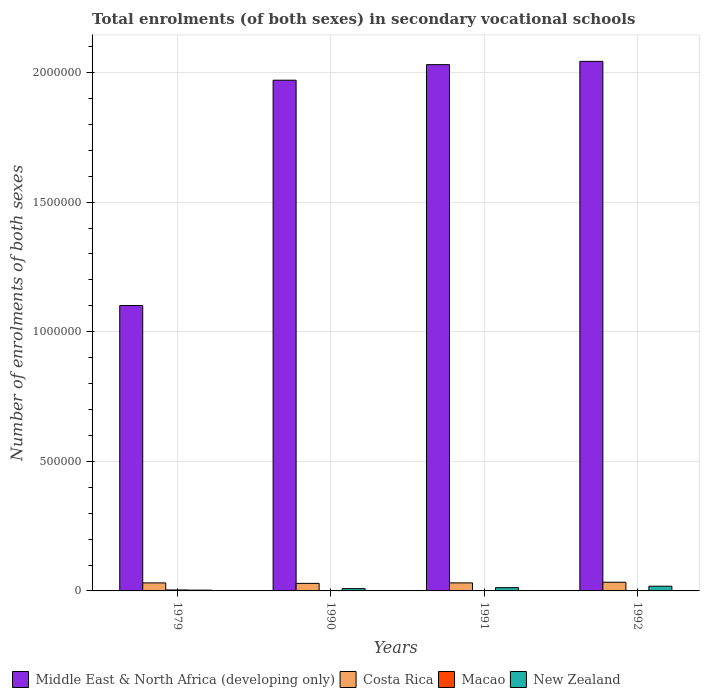How many groups of bars are there?
Ensure brevity in your answer.  4. Are the number of bars per tick equal to the number of legend labels?
Provide a short and direct response. Yes. How many bars are there on the 3rd tick from the left?
Provide a short and direct response. 4. What is the label of the 1st group of bars from the left?
Keep it short and to the point. 1979. What is the number of enrolments in secondary schools in Costa Rica in 1992?
Make the answer very short. 3.35e+04. Across all years, what is the maximum number of enrolments in secondary schools in Costa Rica?
Your answer should be compact. 3.35e+04. Across all years, what is the minimum number of enrolments in secondary schools in Middle East & North Africa (developing only)?
Offer a very short reply. 1.10e+06. In which year was the number of enrolments in secondary schools in New Zealand minimum?
Keep it short and to the point. 1979. What is the total number of enrolments in secondary schools in Middle East & North Africa (developing only) in the graph?
Offer a very short reply. 7.14e+06. What is the difference between the number of enrolments in secondary schools in Middle East & North Africa (developing only) in 1979 and that in 1991?
Your answer should be compact. -9.29e+05. What is the difference between the number of enrolments in secondary schools in Middle East & North Africa (developing only) in 1991 and the number of enrolments in secondary schools in Macao in 1990?
Your answer should be compact. 2.03e+06. What is the average number of enrolments in secondary schools in Middle East & North Africa (developing only) per year?
Provide a short and direct response. 1.79e+06. In the year 1990, what is the difference between the number of enrolments in secondary schools in New Zealand and number of enrolments in secondary schools in Middle East & North Africa (developing only)?
Your response must be concise. -1.96e+06. What is the ratio of the number of enrolments in secondary schools in Macao in 1990 to that in 1991?
Keep it short and to the point. 0.96. What is the difference between the highest and the second highest number of enrolments in secondary schools in Costa Rica?
Provide a succinct answer. 2579. What is the difference between the highest and the lowest number of enrolments in secondary schools in New Zealand?
Your answer should be very brief. 1.52e+04. Is the sum of the number of enrolments in secondary schools in New Zealand in 1991 and 1992 greater than the maximum number of enrolments in secondary schools in Middle East & North Africa (developing only) across all years?
Offer a very short reply. No. Is it the case that in every year, the sum of the number of enrolments in secondary schools in New Zealand and number of enrolments in secondary schools in Middle East & North Africa (developing only) is greater than the sum of number of enrolments in secondary schools in Macao and number of enrolments in secondary schools in Costa Rica?
Provide a succinct answer. No. What does the 4th bar from the left in 1991 represents?
Make the answer very short. New Zealand. What does the 4th bar from the right in 1992 represents?
Your response must be concise. Middle East & North Africa (developing only). Is it the case that in every year, the sum of the number of enrolments in secondary schools in New Zealand and number of enrolments in secondary schools in Macao is greater than the number of enrolments in secondary schools in Costa Rica?
Provide a succinct answer. No. How many years are there in the graph?
Give a very brief answer. 4. What is the difference between two consecutive major ticks on the Y-axis?
Provide a short and direct response. 5.00e+05. Where does the legend appear in the graph?
Your answer should be very brief. Bottom left. How many legend labels are there?
Your answer should be very brief. 4. What is the title of the graph?
Offer a terse response. Total enrolments (of both sexes) in secondary vocational schools. Does "Macao" appear as one of the legend labels in the graph?
Your response must be concise. Yes. What is the label or title of the X-axis?
Your answer should be compact. Years. What is the label or title of the Y-axis?
Keep it short and to the point. Number of enrolments of both sexes. What is the Number of enrolments of both sexes in Middle East & North Africa (developing only) in 1979?
Your answer should be very brief. 1.10e+06. What is the Number of enrolments of both sexes in Costa Rica in 1979?
Ensure brevity in your answer.  3.09e+04. What is the Number of enrolments of both sexes of Macao in 1979?
Offer a very short reply. 3703. What is the Number of enrolments of both sexes of New Zealand in 1979?
Make the answer very short. 2977. What is the Number of enrolments of both sexes in Middle East & North Africa (developing only) in 1990?
Keep it short and to the point. 1.97e+06. What is the Number of enrolments of both sexes in Costa Rica in 1990?
Your answer should be compact. 2.91e+04. What is the Number of enrolments of both sexes of Macao in 1990?
Your answer should be compact. 697. What is the Number of enrolments of both sexes in New Zealand in 1990?
Keep it short and to the point. 8901. What is the Number of enrolments of both sexes of Middle East & North Africa (developing only) in 1991?
Your response must be concise. 2.03e+06. What is the Number of enrolments of both sexes of Costa Rica in 1991?
Provide a succinct answer. 3.10e+04. What is the Number of enrolments of both sexes in Macao in 1991?
Ensure brevity in your answer.  725. What is the Number of enrolments of both sexes in New Zealand in 1991?
Give a very brief answer. 1.25e+04. What is the Number of enrolments of both sexes of Middle East & North Africa (developing only) in 1992?
Your answer should be very brief. 2.04e+06. What is the Number of enrolments of both sexes in Costa Rica in 1992?
Keep it short and to the point. 3.35e+04. What is the Number of enrolments of both sexes of Macao in 1992?
Offer a very short reply. 754. What is the Number of enrolments of both sexes in New Zealand in 1992?
Ensure brevity in your answer.  1.82e+04. Across all years, what is the maximum Number of enrolments of both sexes in Middle East & North Africa (developing only)?
Your response must be concise. 2.04e+06. Across all years, what is the maximum Number of enrolments of both sexes in Costa Rica?
Offer a very short reply. 3.35e+04. Across all years, what is the maximum Number of enrolments of both sexes of Macao?
Make the answer very short. 3703. Across all years, what is the maximum Number of enrolments of both sexes of New Zealand?
Offer a terse response. 1.82e+04. Across all years, what is the minimum Number of enrolments of both sexes in Middle East & North Africa (developing only)?
Keep it short and to the point. 1.10e+06. Across all years, what is the minimum Number of enrolments of both sexes in Costa Rica?
Give a very brief answer. 2.91e+04. Across all years, what is the minimum Number of enrolments of both sexes in Macao?
Keep it short and to the point. 697. Across all years, what is the minimum Number of enrolments of both sexes of New Zealand?
Your answer should be compact. 2977. What is the total Number of enrolments of both sexes in Middle East & North Africa (developing only) in the graph?
Provide a succinct answer. 7.14e+06. What is the total Number of enrolments of both sexes in Costa Rica in the graph?
Your response must be concise. 1.25e+05. What is the total Number of enrolments of both sexes in Macao in the graph?
Give a very brief answer. 5879. What is the total Number of enrolments of both sexes in New Zealand in the graph?
Keep it short and to the point. 4.26e+04. What is the difference between the Number of enrolments of both sexes of Middle East & North Africa (developing only) in 1979 and that in 1990?
Provide a succinct answer. -8.69e+05. What is the difference between the Number of enrolments of both sexes in Costa Rica in 1979 and that in 1990?
Offer a terse response. 1821. What is the difference between the Number of enrolments of both sexes of Macao in 1979 and that in 1990?
Ensure brevity in your answer.  3006. What is the difference between the Number of enrolments of both sexes in New Zealand in 1979 and that in 1990?
Your answer should be compact. -5924. What is the difference between the Number of enrolments of both sexes in Middle East & North Africa (developing only) in 1979 and that in 1991?
Keep it short and to the point. -9.29e+05. What is the difference between the Number of enrolments of both sexes of Costa Rica in 1979 and that in 1991?
Your response must be concise. -36. What is the difference between the Number of enrolments of both sexes of Macao in 1979 and that in 1991?
Offer a terse response. 2978. What is the difference between the Number of enrolments of both sexes of New Zealand in 1979 and that in 1991?
Make the answer very short. -9560. What is the difference between the Number of enrolments of both sexes in Middle East & North Africa (developing only) in 1979 and that in 1992?
Give a very brief answer. -9.42e+05. What is the difference between the Number of enrolments of both sexes of Costa Rica in 1979 and that in 1992?
Keep it short and to the point. -2615. What is the difference between the Number of enrolments of both sexes of Macao in 1979 and that in 1992?
Make the answer very short. 2949. What is the difference between the Number of enrolments of both sexes in New Zealand in 1979 and that in 1992?
Ensure brevity in your answer.  -1.52e+04. What is the difference between the Number of enrolments of both sexes of Middle East & North Africa (developing only) in 1990 and that in 1991?
Make the answer very short. -5.99e+04. What is the difference between the Number of enrolments of both sexes of Costa Rica in 1990 and that in 1991?
Ensure brevity in your answer.  -1857. What is the difference between the Number of enrolments of both sexes of New Zealand in 1990 and that in 1991?
Provide a succinct answer. -3636. What is the difference between the Number of enrolments of both sexes in Middle East & North Africa (developing only) in 1990 and that in 1992?
Your answer should be compact. -7.27e+04. What is the difference between the Number of enrolments of both sexes in Costa Rica in 1990 and that in 1992?
Make the answer very short. -4436. What is the difference between the Number of enrolments of both sexes in Macao in 1990 and that in 1992?
Offer a very short reply. -57. What is the difference between the Number of enrolments of both sexes in New Zealand in 1990 and that in 1992?
Your answer should be very brief. -9249. What is the difference between the Number of enrolments of both sexes of Middle East & North Africa (developing only) in 1991 and that in 1992?
Provide a succinct answer. -1.27e+04. What is the difference between the Number of enrolments of both sexes of Costa Rica in 1991 and that in 1992?
Your answer should be very brief. -2579. What is the difference between the Number of enrolments of both sexes of New Zealand in 1991 and that in 1992?
Your answer should be compact. -5613. What is the difference between the Number of enrolments of both sexes in Middle East & North Africa (developing only) in 1979 and the Number of enrolments of both sexes in Costa Rica in 1990?
Offer a terse response. 1.07e+06. What is the difference between the Number of enrolments of both sexes of Middle East & North Africa (developing only) in 1979 and the Number of enrolments of both sexes of Macao in 1990?
Ensure brevity in your answer.  1.10e+06. What is the difference between the Number of enrolments of both sexes in Middle East & North Africa (developing only) in 1979 and the Number of enrolments of both sexes in New Zealand in 1990?
Keep it short and to the point. 1.09e+06. What is the difference between the Number of enrolments of both sexes in Costa Rica in 1979 and the Number of enrolments of both sexes in Macao in 1990?
Ensure brevity in your answer.  3.02e+04. What is the difference between the Number of enrolments of both sexes in Costa Rica in 1979 and the Number of enrolments of both sexes in New Zealand in 1990?
Provide a succinct answer. 2.20e+04. What is the difference between the Number of enrolments of both sexes in Macao in 1979 and the Number of enrolments of both sexes in New Zealand in 1990?
Your answer should be very brief. -5198. What is the difference between the Number of enrolments of both sexes of Middle East & North Africa (developing only) in 1979 and the Number of enrolments of both sexes of Costa Rica in 1991?
Your answer should be compact. 1.07e+06. What is the difference between the Number of enrolments of both sexes in Middle East & North Africa (developing only) in 1979 and the Number of enrolments of both sexes in Macao in 1991?
Keep it short and to the point. 1.10e+06. What is the difference between the Number of enrolments of both sexes in Middle East & North Africa (developing only) in 1979 and the Number of enrolments of both sexes in New Zealand in 1991?
Make the answer very short. 1.09e+06. What is the difference between the Number of enrolments of both sexes of Costa Rica in 1979 and the Number of enrolments of both sexes of Macao in 1991?
Offer a terse response. 3.02e+04. What is the difference between the Number of enrolments of both sexes in Costa Rica in 1979 and the Number of enrolments of both sexes in New Zealand in 1991?
Ensure brevity in your answer.  1.84e+04. What is the difference between the Number of enrolments of both sexes of Macao in 1979 and the Number of enrolments of both sexes of New Zealand in 1991?
Offer a very short reply. -8834. What is the difference between the Number of enrolments of both sexes in Middle East & North Africa (developing only) in 1979 and the Number of enrolments of both sexes in Costa Rica in 1992?
Keep it short and to the point. 1.07e+06. What is the difference between the Number of enrolments of both sexes of Middle East & North Africa (developing only) in 1979 and the Number of enrolments of both sexes of Macao in 1992?
Offer a very short reply. 1.10e+06. What is the difference between the Number of enrolments of both sexes of Middle East & North Africa (developing only) in 1979 and the Number of enrolments of both sexes of New Zealand in 1992?
Your response must be concise. 1.08e+06. What is the difference between the Number of enrolments of both sexes of Costa Rica in 1979 and the Number of enrolments of both sexes of Macao in 1992?
Provide a succinct answer. 3.02e+04. What is the difference between the Number of enrolments of both sexes in Costa Rica in 1979 and the Number of enrolments of both sexes in New Zealand in 1992?
Your answer should be very brief. 1.28e+04. What is the difference between the Number of enrolments of both sexes in Macao in 1979 and the Number of enrolments of both sexes in New Zealand in 1992?
Your answer should be compact. -1.44e+04. What is the difference between the Number of enrolments of both sexes of Middle East & North Africa (developing only) in 1990 and the Number of enrolments of both sexes of Costa Rica in 1991?
Provide a succinct answer. 1.94e+06. What is the difference between the Number of enrolments of both sexes of Middle East & North Africa (developing only) in 1990 and the Number of enrolments of both sexes of Macao in 1991?
Ensure brevity in your answer.  1.97e+06. What is the difference between the Number of enrolments of both sexes in Middle East & North Africa (developing only) in 1990 and the Number of enrolments of both sexes in New Zealand in 1991?
Your answer should be compact. 1.96e+06. What is the difference between the Number of enrolments of both sexes of Costa Rica in 1990 and the Number of enrolments of both sexes of Macao in 1991?
Make the answer very short. 2.84e+04. What is the difference between the Number of enrolments of both sexes in Costa Rica in 1990 and the Number of enrolments of both sexes in New Zealand in 1991?
Provide a short and direct response. 1.66e+04. What is the difference between the Number of enrolments of both sexes of Macao in 1990 and the Number of enrolments of both sexes of New Zealand in 1991?
Provide a short and direct response. -1.18e+04. What is the difference between the Number of enrolments of both sexes in Middle East & North Africa (developing only) in 1990 and the Number of enrolments of both sexes in Costa Rica in 1992?
Make the answer very short. 1.94e+06. What is the difference between the Number of enrolments of both sexes of Middle East & North Africa (developing only) in 1990 and the Number of enrolments of both sexes of Macao in 1992?
Make the answer very short. 1.97e+06. What is the difference between the Number of enrolments of both sexes in Middle East & North Africa (developing only) in 1990 and the Number of enrolments of both sexes in New Zealand in 1992?
Offer a very short reply. 1.95e+06. What is the difference between the Number of enrolments of both sexes of Costa Rica in 1990 and the Number of enrolments of both sexes of Macao in 1992?
Your response must be concise. 2.83e+04. What is the difference between the Number of enrolments of both sexes of Costa Rica in 1990 and the Number of enrolments of both sexes of New Zealand in 1992?
Your answer should be very brief. 1.10e+04. What is the difference between the Number of enrolments of both sexes in Macao in 1990 and the Number of enrolments of both sexes in New Zealand in 1992?
Your response must be concise. -1.75e+04. What is the difference between the Number of enrolments of both sexes in Middle East & North Africa (developing only) in 1991 and the Number of enrolments of both sexes in Costa Rica in 1992?
Offer a terse response. 2.00e+06. What is the difference between the Number of enrolments of both sexes in Middle East & North Africa (developing only) in 1991 and the Number of enrolments of both sexes in Macao in 1992?
Provide a short and direct response. 2.03e+06. What is the difference between the Number of enrolments of both sexes of Middle East & North Africa (developing only) in 1991 and the Number of enrolments of both sexes of New Zealand in 1992?
Your answer should be compact. 2.01e+06. What is the difference between the Number of enrolments of both sexes in Costa Rica in 1991 and the Number of enrolments of both sexes in Macao in 1992?
Give a very brief answer. 3.02e+04. What is the difference between the Number of enrolments of both sexes of Costa Rica in 1991 and the Number of enrolments of both sexes of New Zealand in 1992?
Your answer should be very brief. 1.28e+04. What is the difference between the Number of enrolments of both sexes of Macao in 1991 and the Number of enrolments of both sexes of New Zealand in 1992?
Ensure brevity in your answer.  -1.74e+04. What is the average Number of enrolments of both sexes in Middle East & North Africa (developing only) per year?
Your answer should be very brief. 1.79e+06. What is the average Number of enrolments of both sexes in Costa Rica per year?
Your answer should be compact. 3.11e+04. What is the average Number of enrolments of both sexes in Macao per year?
Provide a short and direct response. 1469.75. What is the average Number of enrolments of both sexes of New Zealand per year?
Keep it short and to the point. 1.06e+04. In the year 1979, what is the difference between the Number of enrolments of both sexes in Middle East & North Africa (developing only) and Number of enrolments of both sexes in Costa Rica?
Ensure brevity in your answer.  1.07e+06. In the year 1979, what is the difference between the Number of enrolments of both sexes of Middle East & North Africa (developing only) and Number of enrolments of both sexes of Macao?
Your answer should be very brief. 1.10e+06. In the year 1979, what is the difference between the Number of enrolments of both sexes in Middle East & North Africa (developing only) and Number of enrolments of both sexes in New Zealand?
Your answer should be very brief. 1.10e+06. In the year 1979, what is the difference between the Number of enrolments of both sexes of Costa Rica and Number of enrolments of both sexes of Macao?
Your response must be concise. 2.72e+04. In the year 1979, what is the difference between the Number of enrolments of both sexes of Costa Rica and Number of enrolments of both sexes of New Zealand?
Your answer should be compact. 2.79e+04. In the year 1979, what is the difference between the Number of enrolments of both sexes in Macao and Number of enrolments of both sexes in New Zealand?
Your response must be concise. 726. In the year 1990, what is the difference between the Number of enrolments of both sexes in Middle East & North Africa (developing only) and Number of enrolments of both sexes in Costa Rica?
Make the answer very short. 1.94e+06. In the year 1990, what is the difference between the Number of enrolments of both sexes in Middle East & North Africa (developing only) and Number of enrolments of both sexes in Macao?
Keep it short and to the point. 1.97e+06. In the year 1990, what is the difference between the Number of enrolments of both sexes in Middle East & North Africa (developing only) and Number of enrolments of both sexes in New Zealand?
Make the answer very short. 1.96e+06. In the year 1990, what is the difference between the Number of enrolments of both sexes in Costa Rica and Number of enrolments of both sexes in Macao?
Give a very brief answer. 2.84e+04. In the year 1990, what is the difference between the Number of enrolments of both sexes of Costa Rica and Number of enrolments of both sexes of New Zealand?
Your answer should be compact. 2.02e+04. In the year 1990, what is the difference between the Number of enrolments of both sexes in Macao and Number of enrolments of both sexes in New Zealand?
Make the answer very short. -8204. In the year 1991, what is the difference between the Number of enrolments of both sexes in Middle East & North Africa (developing only) and Number of enrolments of both sexes in Costa Rica?
Offer a very short reply. 2.00e+06. In the year 1991, what is the difference between the Number of enrolments of both sexes of Middle East & North Africa (developing only) and Number of enrolments of both sexes of Macao?
Offer a very short reply. 2.03e+06. In the year 1991, what is the difference between the Number of enrolments of both sexes of Middle East & North Africa (developing only) and Number of enrolments of both sexes of New Zealand?
Keep it short and to the point. 2.02e+06. In the year 1991, what is the difference between the Number of enrolments of both sexes of Costa Rica and Number of enrolments of both sexes of Macao?
Make the answer very short. 3.02e+04. In the year 1991, what is the difference between the Number of enrolments of both sexes in Costa Rica and Number of enrolments of both sexes in New Zealand?
Make the answer very short. 1.84e+04. In the year 1991, what is the difference between the Number of enrolments of both sexes in Macao and Number of enrolments of both sexes in New Zealand?
Ensure brevity in your answer.  -1.18e+04. In the year 1992, what is the difference between the Number of enrolments of both sexes in Middle East & North Africa (developing only) and Number of enrolments of both sexes in Costa Rica?
Offer a terse response. 2.01e+06. In the year 1992, what is the difference between the Number of enrolments of both sexes of Middle East & North Africa (developing only) and Number of enrolments of both sexes of Macao?
Provide a succinct answer. 2.04e+06. In the year 1992, what is the difference between the Number of enrolments of both sexes of Middle East & North Africa (developing only) and Number of enrolments of both sexes of New Zealand?
Provide a short and direct response. 2.02e+06. In the year 1992, what is the difference between the Number of enrolments of both sexes of Costa Rica and Number of enrolments of both sexes of Macao?
Keep it short and to the point. 3.28e+04. In the year 1992, what is the difference between the Number of enrolments of both sexes of Costa Rica and Number of enrolments of both sexes of New Zealand?
Give a very brief answer. 1.54e+04. In the year 1992, what is the difference between the Number of enrolments of both sexes of Macao and Number of enrolments of both sexes of New Zealand?
Provide a short and direct response. -1.74e+04. What is the ratio of the Number of enrolments of both sexes of Middle East & North Africa (developing only) in 1979 to that in 1990?
Offer a terse response. 0.56. What is the ratio of the Number of enrolments of both sexes of Costa Rica in 1979 to that in 1990?
Provide a succinct answer. 1.06. What is the ratio of the Number of enrolments of both sexes of Macao in 1979 to that in 1990?
Offer a very short reply. 5.31. What is the ratio of the Number of enrolments of both sexes in New Zealand in 1979 to that in 1990?
Provide a succinct answer. 0.33. What is the ratio of the Number of enrolments of both sexes in Middle East & North Africa (developing only) in 1979 to that in 1991?
Your answer should be compact. 0.54. What is the ratio of the Number of enrolments of both sexes in Macao in 1979 to that in 1991?
Ensure brevity in your answer.  5.11. What is the ratio of the Number of enrolments of both sexes of New Zealand in 1979 to that in 1991?
Offer a terse response. 0.24. What is the ratio of the Number of enrolments of both sexes in Middle East & North Africa (developing only) in 1979 to that in 1992?
Your response must be concise. 0.54. What is the ratio of the Number of enrolments of both sexes of Costa Rica in 1979 to that in 1992?
Offer a very short reply. 0.92. What is the ratio of the Number of enrolments of both sexes in Macao in 1979 to that in 1992?
Offer a terse response. 4.91. What is the ratio of the Number of enrolments of both sexes in New Zealand in 1979 to that in 1992?
Provide a short and direct response. 0.16. What is the ratio of the Number of enrolments of both sexes of Middle East & North Africa (developing only) in 1990 to that in 1991?
Provide a succinct answer. 0.97. What is the ratio of the Number of enrolments of both sexes of Costa Rica in 1990 to that in 1991?
Ensure brevity in your answer.  0.94. What is the ratio of the Number of enrolments of both sexes of Macao in 1990 to that in 1991?
Offer a terse response. 0.96. What is the ratio of the Number of enrolments of both sexes in New Zealand in 1990 to that in 1991?
Your response must be concise. 0.71. What is the ratio of the Number of enrolments of both sexes of Middle East & North Africa (developing only) in 1990 to that in 1992?
Provide a succinct answer. 0.96. What is the ratio of the Number of enrolments of both sexes in Costa Rica in 1990 to that in 1992?
Your answer should be very brief. 0.87. What is the ratio of the Number of enrolments of both sexes in Macao in 1990 to that in 1992?
Your answer should be very brief. 0.92. What is the ratio of the Number of enrolments of both sexes in New Zealand in 1990 to that in 1992?
Your answer should be compact. 0.49. What is the ratio of the Number of enrolments of both sexes of Middle East & North Africa (developing only) in 1991 to that in 1992?
Your answer should be very brief. 0.99. What is the ratio of the Number of enrolments of both sexes of Costa Rica in 1991 to that in 1992?
Make the answer very short. 0.92. What is the ratio of the Number of enrolments of both sexes in Macao in 1991 to that in 1992?
Offer a very short reply. 0.96. What is the ratio of the Number of enrolments of both sexes in New Zealand in 1991 to that in 1992?
Give a very brief answer. 0.69. What is the difference between the highest and the second highest Number of enrolments of both sexes of Middle East & North Africa (developing only)?
Give a very brief answer. 1.27e+04. What is the difference between the highest and the second highest Number of enrolments of both sexes in Costa Rica?
Give a very brief answer. 2579. What is the difference between the highest and the second highest Number of enrolments of both sexes in Macao?
Make the answer very short. 2949. What is the difference between the highest and the second highest Number of enrolments of both sexes of New Zealand?
Provide a short and direct response. 5613. What is the difference between the highest and the lowest Number of enrolments of both sexes in Middle East & North Africa (developing only)?
Make the answer very short. 9.42e+05. What is the difference between the highest and the lowest Number of enrolments of both sexes of Costa Rica?
Your answer should be compact. 4436. What is the difference between the highest and the lowest Number of enrolments of both sexes of Macao?
Offer a terse response. 3006. What is the difference between the highest and the lowest Number of enrolments of both sexes of New Zealand?
Your answer should be compact. 1.52e+04. 